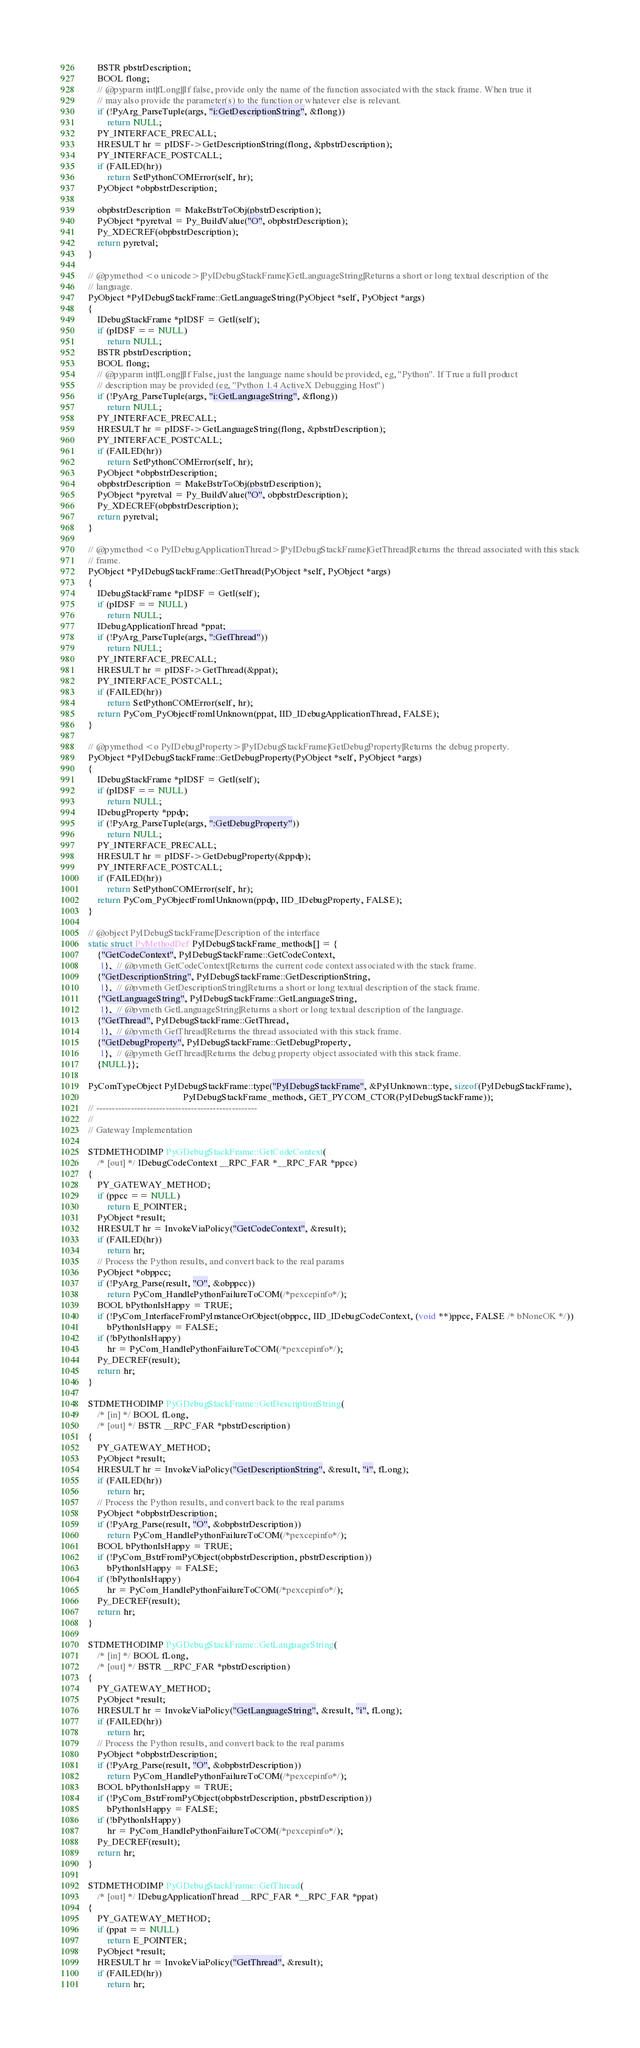Convert code to text. <code><loc_0><loc_0><loc_500><loc_500><_C++_>    BSTR pbstrDescription;
    BOOL flong;
    // @pyparm int|fLong||If false, provide only the name of the function associated with the stack frame. When true it
    // may also provide the parameter(s) to the function or whatever else is relevant.
    if (!PyArg_ParseTuple(args, "i:GetDescriptionString", &flong))
        return NULL;
    PY_INTERFACE_PRECALL;
    HRESULT hr = pIDSF->GetDescriptionString(flong, &pbstrDescription);
    PY_INTERFACE_POSTCALL;
    if (FAILED(hr))
        return SetPythonCOMError(self, hr);
    PyObject *obpbstrDescription;

    obpbstrDescription = MakeBstrToObj(pbstrDescription);
    PyObject *pyretval = Py_BuildValue("O", obpbstrDescription);
    Py_XDECREF(obpbstrDescription);
    return pyretval;
}

// @pymethod <o unicode>|PyIDebugStackFrame|GetLanguageString|Returns a short or long textual description of the
// language.
PyObject *PyIDebugStackFrame::GetLanguageString(PyObject *self, PyObject *args)
{
    IDebugStackFrame *pIDSF = GetI(self);
    if (pIDSF == NULL)
        return NULL;
    BSTR pbstrDescription;
    BOOL flong;
    // @pyparm int|fLong||If False, just the language name should be provided, eg, "Python". If True a full product
    // description may be provided (eg, "Python 1.4 ActiveX Debugging Host")
    if (!PyArg_ParseTuple(args, "i:GetLanguageString", &flong))
        return NULL;
    PY_INTERFACE_PRECALL;
    HRESULT hr = pIDSF->GetLanguageString(flong, &pbstrDescription);
    PY_INTERFACE_POSTCALL;
    if (FAILED(hr))
        return SetPythonCOMError(self, hr);
    PyObject *obpbstrDescription;
    obpbstrDescription = MakeBstrToObj(pbstrDescription);
    PyObject *pyretval = Py_BuildValue("O", obpbstrDescription);
    Py_XDECREF(obpbstrDescription);
    return pyretval;
}

// @pymethod <o PyIDebugApplicationThread>|PyIDebugStackFrame|GetThread|Returns the thread associated with this stack
// frame.
PyObject *PyIDebugStackFrame::GetThread(PyObject *self, PyObject *args)
{
    IDebugStackFrame *pIDSF = GetI(self);
    if (pIDSF == NULL)
        return NULL;
    IDebugApplicationThread *ppat;
    if (!PyArg_ParseTuple(args, ":GetThread"))
        return NULL;
    PY_INTERFACE_PRECALL;
    HRESULT hr = pIDSF->GetThread(&ppat);
    PY_INTERFACE_POSTCALL;
    if (FAILED(hr))
        return SetPythonCOMError(self, hr);
    return PyCom_PyObjectFromIUnknown(ppat, IID_IDebugApplicationThread, FALSE);
}

// @pymethod <o PyIDebugProperty>|PyIDebugStackFrame|GetDebugProperty|Returns the debug property.
PyObject *PyIDebugStackFrame::GetDebugProperty(PyObject *self, PyObject *args)
{
    IDebugStackFrame *pIDSF = GetI(self);
    if (pIDSF == NULL)
        return NULL;
    IDebugProperty *ppdp;
    if (!PyArg_ParseTuple(args, ":GetDebugProperty"))
        return NULL;
    PY_INTERFACE_PRECALL;
    HRESULT hr = pIDSF->GetDebugProperty(&ppdp);
    PY_INTERFACE_POSTCALL;
    if (FAILED(hr))
        return SetPythonCOMError(self, hr);
    return PyCom_PyObjectFromIUnknown(ppdp, IID_IDebugProperty, FALSE);
}

// @object PyIDebugStackFrame|Description of the interface
static struct PyMethodDef PyIDebugStackFrame_methods[] = {
    {"GetCodeContext", PyIDebugStackFrame::GetCodeContext,
     1},  // @pymeth GetCodeContext|Returns the current code context associated with the stack frame.
    {"GetDescriptionString", PyIDebugStackFrame::GetDescriptionString,
     1},  // @pymeth GetDescriptionString|Returns a short or long textual description of the stack frame.
    {"GetLanguageString", PyIDebugStackFrame::GetLanguageString,
     1},  // @pymeth GetLanguageString|Returns a short or long textual description of the language.
    {"GetThread", PyIDebugStackFrame::GetThread,
     1},  // @pymeth GetThread|Returns the thread associated with this stack frame.
    {"GetDebugProperty", PyIDebugStackFrame::GetDebugProperty,
     1},  // @pymeth GetThread|Returns the debug property object associated with this stack frame.
    {NULL}};

PyComTypeObject PyIDebugStackFrame::type("PyIDebugStackFrame", &PyIUnknown::type, sizeof(PyIDebugStackFrame),
                                         PyIDebugStackFrame_methods, GET_PYCOM_CTOR(PyIDebugStackFrame));
// ---------------------------------------------------
//
// Gateway Implementation

STDMETHODIMP PyGDebugStackFrame::GetCodeContext(
    /* [out] */ IDebugCodeContext __RPC_FAR *__RPC_FAR *ppcc)
{
    PY_GATEWAY_METHOD;
    if (ppcc == NULL)
        return E_POINTER;
    PyObject *result;
    HRESULT hr = InvokeViaPolicy("GetCodeContext", &result);
    if (FAILED(hr))
        return hr;
    // Process the Python results, and convert back to the real params
    PyObject *obppcc;
    if (!PyArg_Parse(result, "O", &obppcc))
        return PyCom_HandlePythonFailureToCOM(/*pexcepinfo*/);
    BOOL bPythonIsHappy = TRUE;
    if (!PyCom_InterfaceFromPyInstanceOrObject(obppcc, IID_IDebugCodeContext, (void **)ppcc, FALSE /* bNoneOK */))
        bPythonIsHappy = FALSE;
    if (!bPythonIsHappy)
        hr = PyCom_HandlePythonFailureToCOM(/*pexcepinfo*/);
    Py_DECREF(result);
    return hr;
}

STDMETHODIMP PyGDebugStackFrame::GetDescriptionString(
    /* [in] */ BOOL fLong,
    /* [out] */ BSTR __RPC_FAR *pbstrDescription)
{
    PY_GATEWAY_METHOD;
    PyObject *result;
    HRESULT hr = InvokeViaPolicy("GetDescriptionString", &result, "i", fLong);
    if (FAILED(hr))
        return hr;
    // Process the Python results, and convert back to the real params
    PyObject *obpbstrDescription;
    if (!PyArg_Parse(result, "O", &obpbstrDescription))
        return PyCom_HandlePythonFailureToCOM(/*pexcepinfo*/);
    BOOL bPythonIsHappy = TRUE;
    if (!PyCom_BstrFromPyObject(obpbstrDescription, pbstrDescription))
        bPythonIsHappy = FALSE;
    if (!bPythonIsHappy)
        hr = PyCom_HandlePythonFailureToCOM(/*pexcepinfo*/);
    Py_DECREF(result);
    return hr;
}

STDMETHODIMP PyGDebugStackFrame::GetLanguageString(
    /* [in] */ BOOL fLong,
    /* [out] */ BSTR __RPC_FAR *pbstrDescription)
{
    PY_GATEWAY_METHOD;
    PyObject *result;
    HRESULT hr = InvokeViaPolicy("GetLanguageString", &result, "i", fLong);
    if (FAILED(hr))
        return hr;
    // Process the Python results, and convert back to the real params
    PyObject *obpbstrDescription;
    if (!PyArg_Parse(result, "O", &obpbstrDescription))
        return PyCom_HandlePythonFailureToCOM(/*pexcepinfo*/);
    BOOL bPythonIsHappy = TRUE;
    if (!PyCom_BstrFromPyObject(obpbstrDescription, pbstrDescription))
        bPythonIsHappy = FALSE;
    if (!bPythonIsHappy)
        hr = PyCom_HandlePythonFailureToCOM(/*pexcepinfo*/);
    Py_DECREF(result);
    return hr;
}

STDMETHODIMP PyGDebugStackFrame::GetThread(
    /* [out] */ IDebugApplicationThread __RPC_FAR *__RPC_FAR *ppat)
{
    PY_GATEWAY_METHOD;
    if (ppat == NULL)
        return E_POINTER;
    PyObject *result;
    HRESULT hr = InvokeViaPolicy("GetThread", &result);
    if (FAILED(hr))
        return hr;</code> 